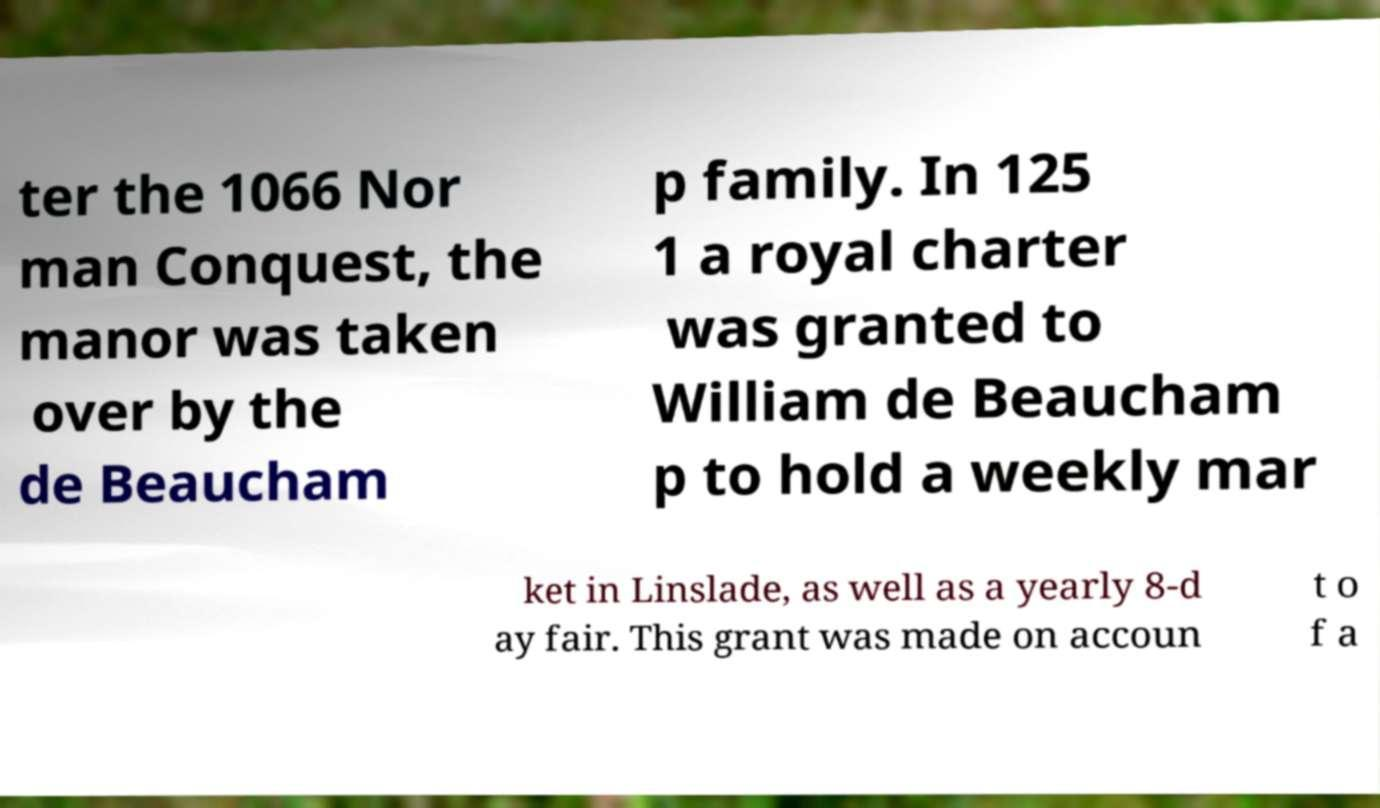Please identify and transcribe the text found in this image. ter the 1066 Nor man Conquest, the manor was taken over by the de Beaucham p family. In 125 1 a royal charter was granted to William de Beaucham p to hold a weekly mar ket in Linslade, as well as a yearly 8-d ay fair. This grant was made on accoun t o f a 